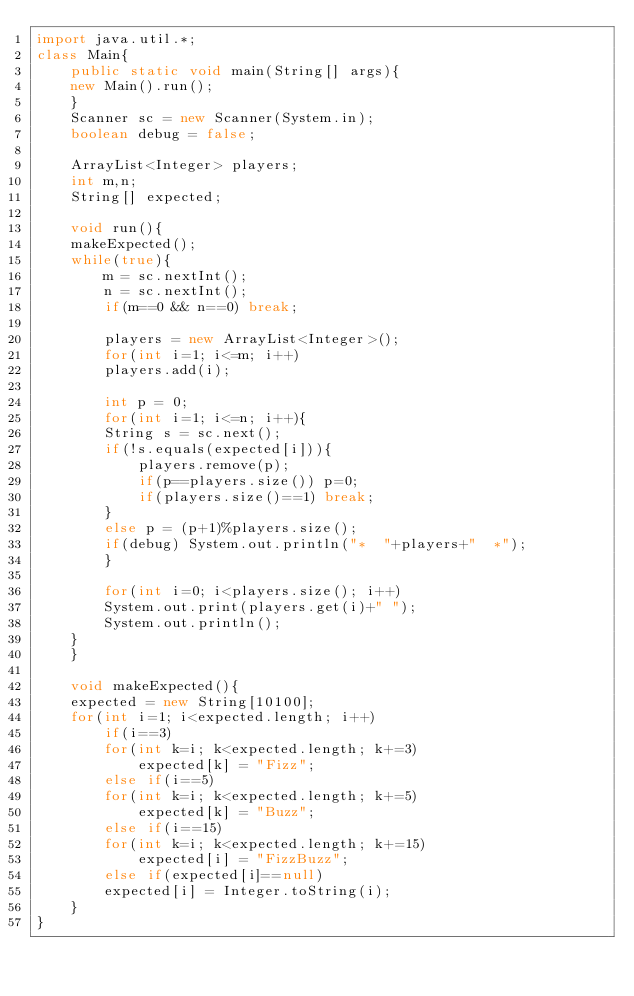<code> <loc_0><loc_0><loc_500><loc_500><_Java_>import java.util.*;
class Main{
    public static void main(String[] args){
	new Main().run();
    }
    Scanner sc = new Scanner(System.in);
    boolean debug = false;

    ArrayList<Integer> players;
    int m,n;
    String[] expected;

    void run(){
	makeExpected();
	while(true){
	    m = sc.nextInt();
	    n = sc.nextInt();
	    if(m==0 && n==0) break;

	    players = new ArrayList<Integer>();
	    for(int i=1; i<=m; i++)
		players.add(i);

	    int p = 0;
	    for(int i=1; i<=n; i++){
		String s = sc.next();
		if(!s.equals(expected[i])){
		    players.remove(p);
		    if(p==players.size()) p=0;
		    if(players.size()==1) break;
		}
		else p = (p+1)%players.size();
		if(debug) System.out.println("*  "+players+"  *");
	    }

	    for(int i=0; i<players.size(); i++)
		System.out.print(players.get(i)+" ");
	    System.out.println();
	}
    }

    void makeExpected(){
	expected = new String[10100];
	for(int i=1; i<expected.length; i++)
	    if(i==3)
		for(int k=i; k<expected.length; k+=3)
		    expected[k] = "Fizz";
	    else if(i==5)
		for(int k=i; k<expected.length; k+=5)
		    expected[k] = "Buzz";
	    else if(i==15)
		for(int k=i; k<expected.length; k+=15)
		    expected[i] = "FizzBuzz";
	    else if(expected[i]==null)
		expected[i] = Integer.toString(i);
    }
}</code> 